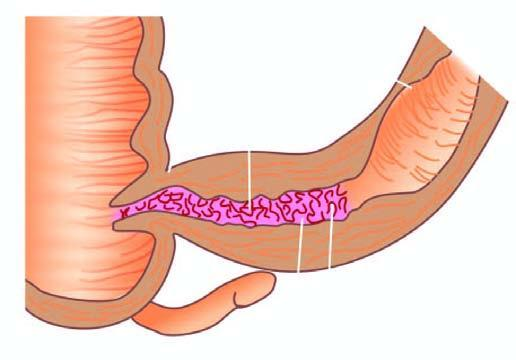s the specimen of small intestine shown in longitudinal section along with a segment in cross section?
Answer the question using a single word or phrase. Yes 